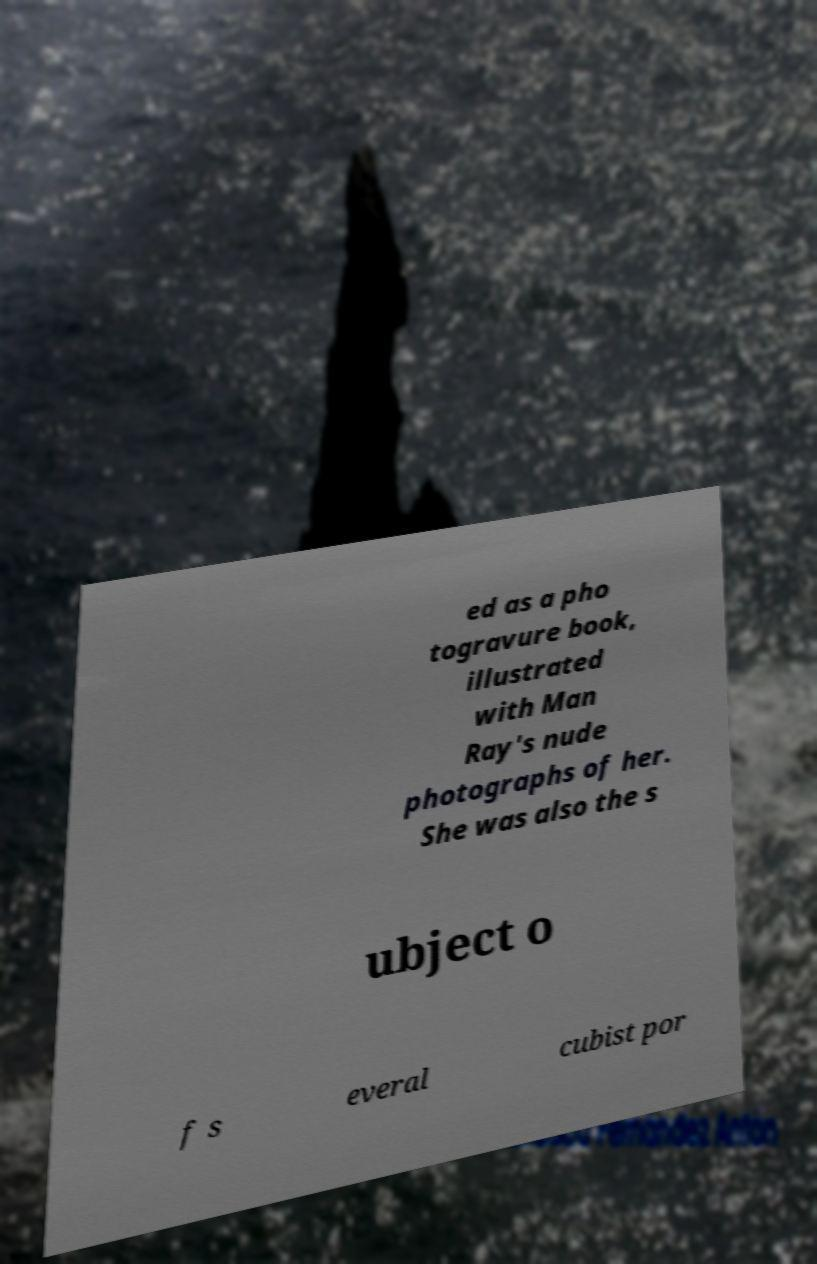There's text embedded in this image that I need extracted. Can you transcribe it verbatim? ed as a pho togravure book, illustrated with Man Ray's nude photographs of her. She was also the s ubject o f s everal cubist por 